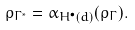Convert formula to latex. <formula><loc_0><loc_0><loc_500><loc_500>\rho _ { \Gamma ^ { * } } = \alpha _ { H ^ { \bullet } ( d ) } ( \rho _ { \Gamma } ) .</formula> 